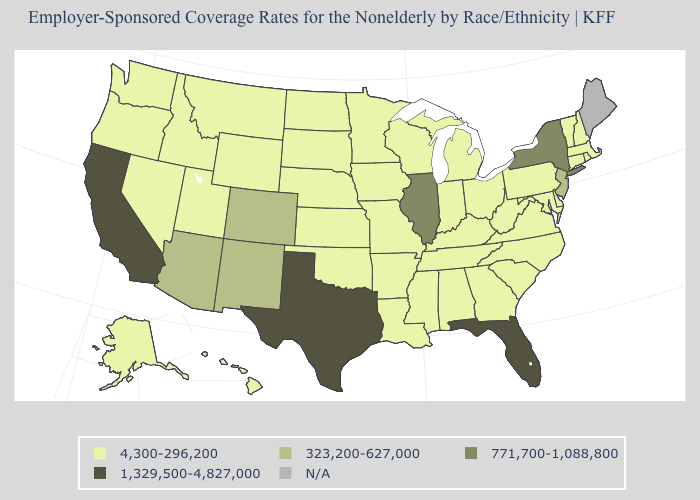What is the lowest value in states that border Michigan?
Be succinct. 4,300-296,200. Does the first symbol in the legend represent the smallest category?
Short answer required. Yes. Among the states that border Rhode Island , which have the highest value?
Short answer required. Connecticut, Massachusetts. What is the value of Mississippi?
Quick response, please. 4,300-296,200. Name the states that have a value in the range 4,300-296,200?
Keep it brief. Alabama, Alaska, Arkansas, Connecticut, Delaware, Georgia, Hawaii, Idaho, Indiana, Iowa, Kansas, Kentucky, Louisiana, Maryland, Massachusetts, Michigan, Minnesota, Mississippi, Missouri, Montana, Nebraska, Nevada, New Hampshire, North Carolina, North Dakota, Ohio, Oklahoma, Oregon, Pennsylvania, Rhode Island, South Carolina, South Dakota, Tennessee, Utah, Vermont, Virginia, Washington, West Virginia, Wisconsin, Wyoming. What is the value of Massachusetts?
Give a very brief answer. 4,300-296,200. Does Florida have the highest value in the USA?
Be succinct. Yes. Which states hav the highest value in the MidWest?
Quick response, please. Illinois. Name the states that have a value in the range N/A?
Keep it brief. Maine. What is the value of Montana?
Give a very brief answer. 4,300-296,200. Name the states that have a value in the range 1,329,500-4,827,000?
Keep it brief. California, Florida, Texas. Name the states that have a value in the range 771,700-1,088,800?
Be succinct. Illinois, New York. 